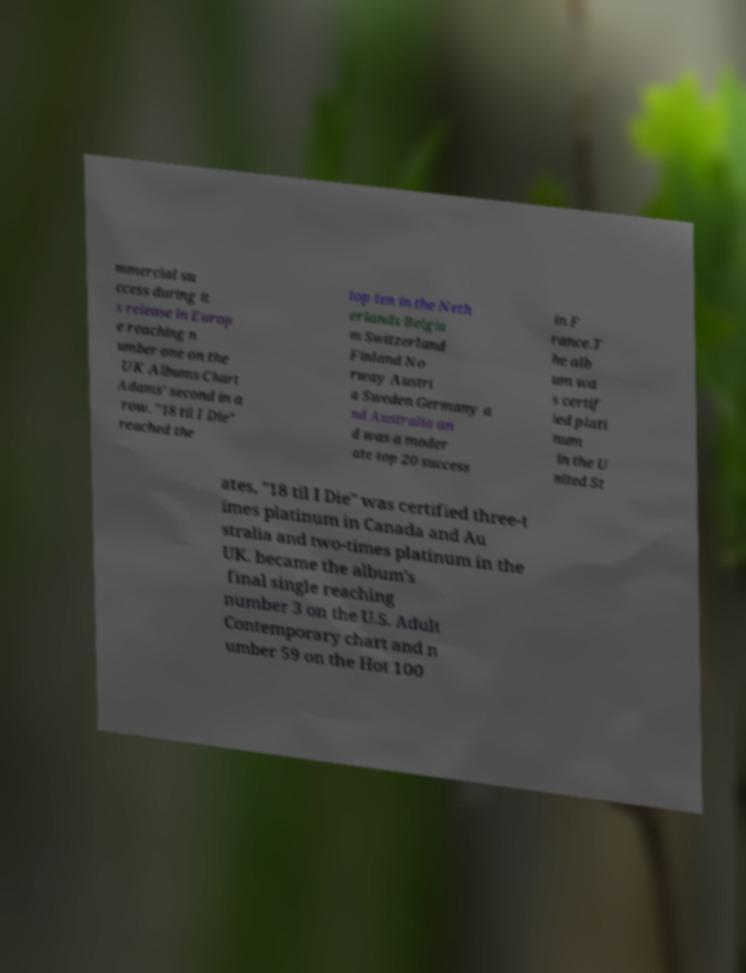Can you read and provide the text displayed in the image?This photo seems to have some interesting text. Can you extract and type it out for me? mmercial su ccess during it s release in Europ e reaching n umber one on the UK Albums Chart Adams' second in a row. "18 til I Die" reached the top ten in the Neth erlands Belgiu m Switzerland Finland No rway Austri a Sweden Germany a nd Australia an d was a moder ate top 20 success in F rance.T he alb um wa s certif ied plati num in the U nited St ates, "18 til I Die" was certified three-t imes platinum in Canada and Au stralia and two-times platinum in the UK. became the album's final single reaching number 3 on the U.S. Adult Contemporary chart and n umber 59 on the Hot 100 